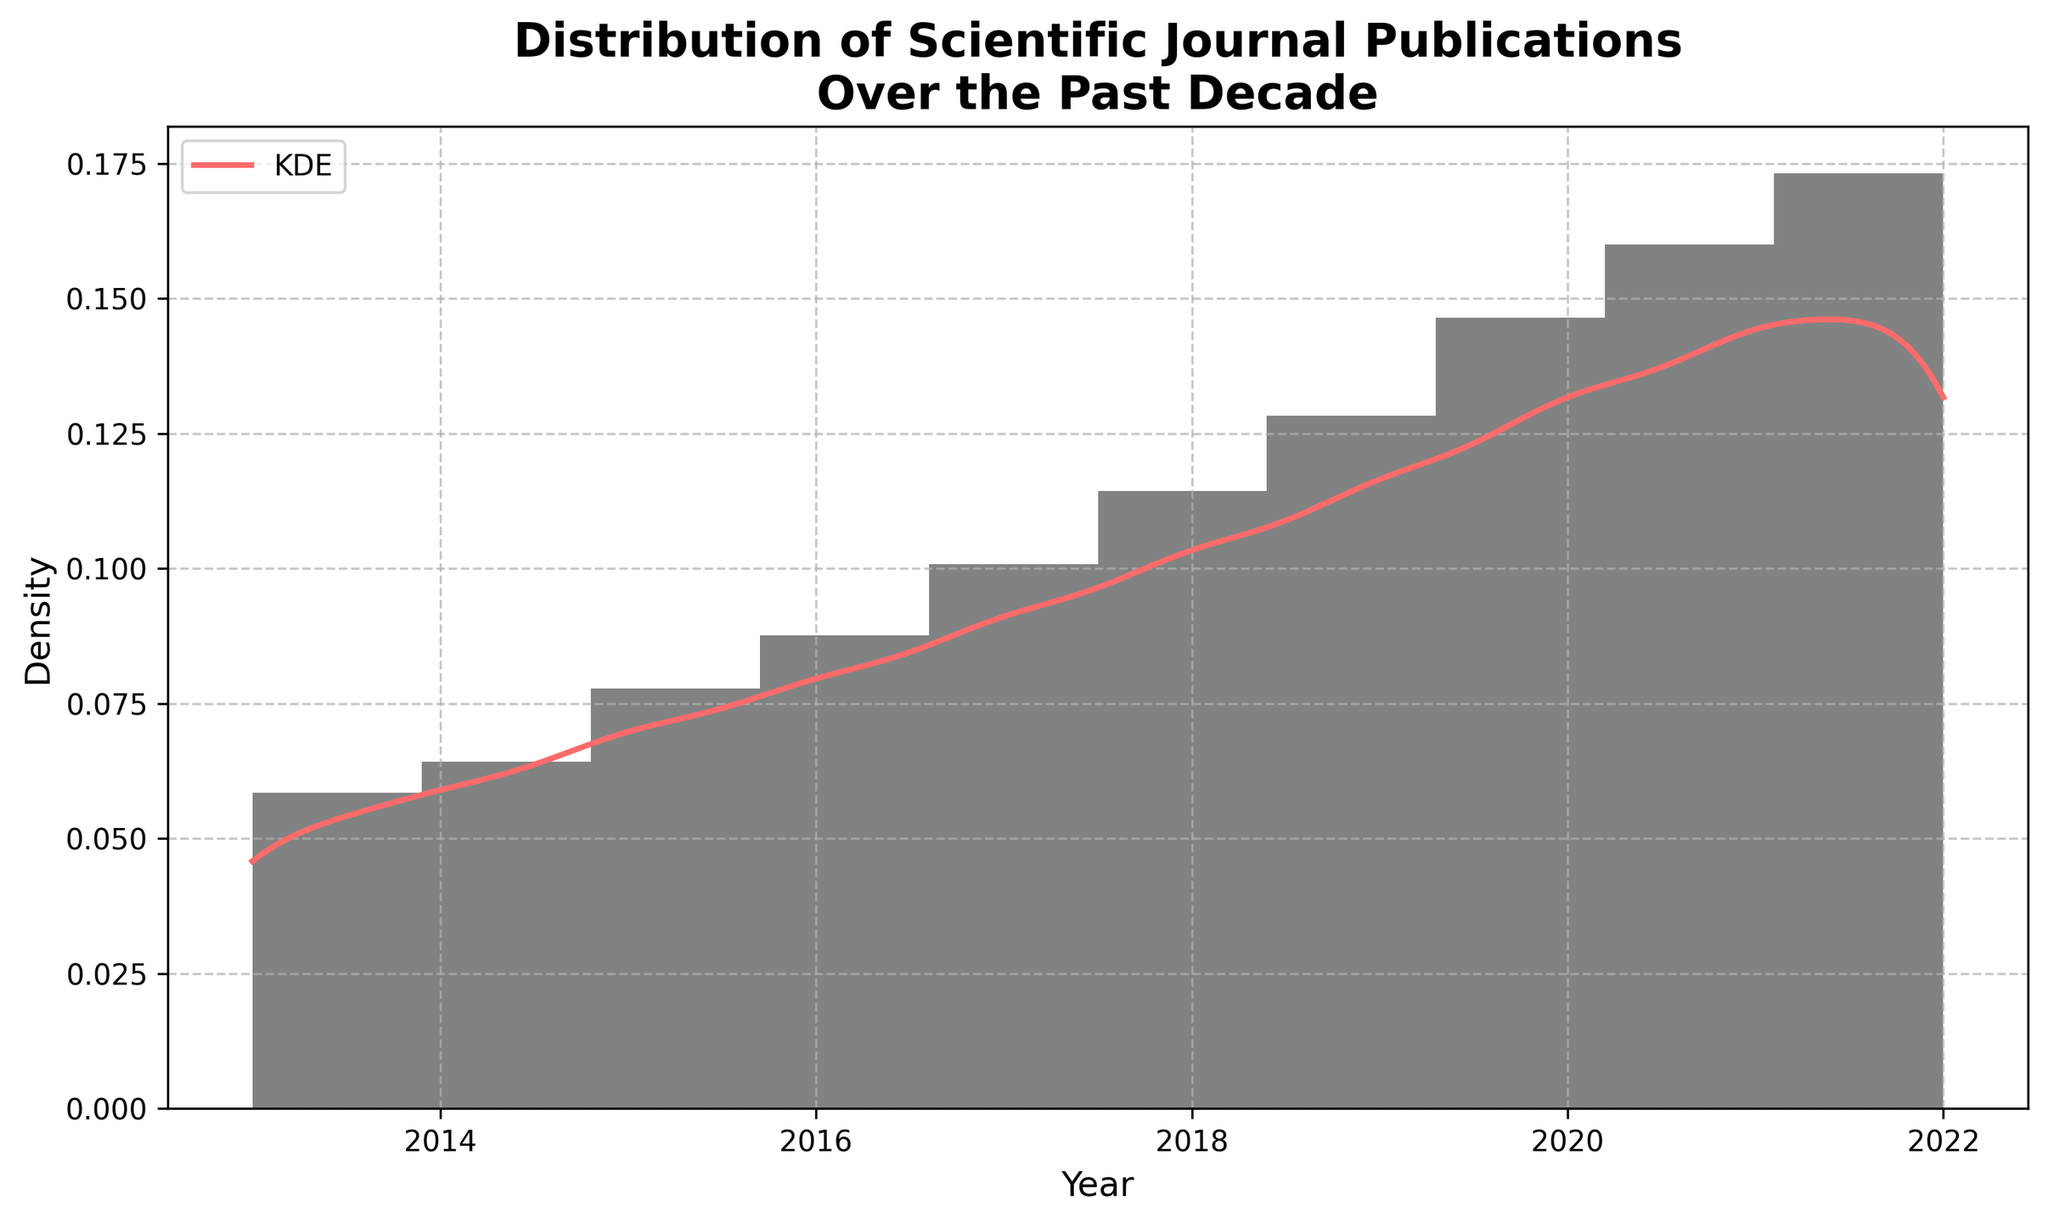What is the title of the figure? The title is the text displayed at the top of the plot, summarizing what the figure represents.
Answer: Distribution of Scientific Journal Publications Over the Past Decade What does the x-axis represent? The x-axis is labeled, indicating what it measures.
Answer: Year What is the color of the histogram bars? The histogram bars have a specific color, easily identifiable in the plot.
Answer: Gray Which year had the highest publication density according to the KDE curve? Identify the peak of the red KDE curve on the x-axis to find the corresponding year with the highest density.
Answer: 2022 How many years does the histogram cover? Count the number of distinct year bins displayed on the x-axis of the histogram.
Answer: 10 Which year had the fastest growth in publications compared to the previous year? Find the year with the steepest incline when moving from one bar to the next on the histogram.
Answer: 2020 What is the difference in publication count between 2017 and 2020? Subtract the number of publications in 2017 from the number in 2020.
Answer: 356 - 245 = 111 How did the publication counts change from 2013 to 2016? Analyze the trend of the bars from 2013 to 2016 to describe the general pattern.
Answer: Increasing Is the distribution of publication dates skewed, according to the KDE? Observe the shape and symmetry of the KDE curve to identify skewness.
Answer: Positively skewed Which year marks the start of a noticeable upward trend in publication counts? Look at the histogram and KDE to identify the first year showing a significant increase in publication counts.
Answer: 2015 